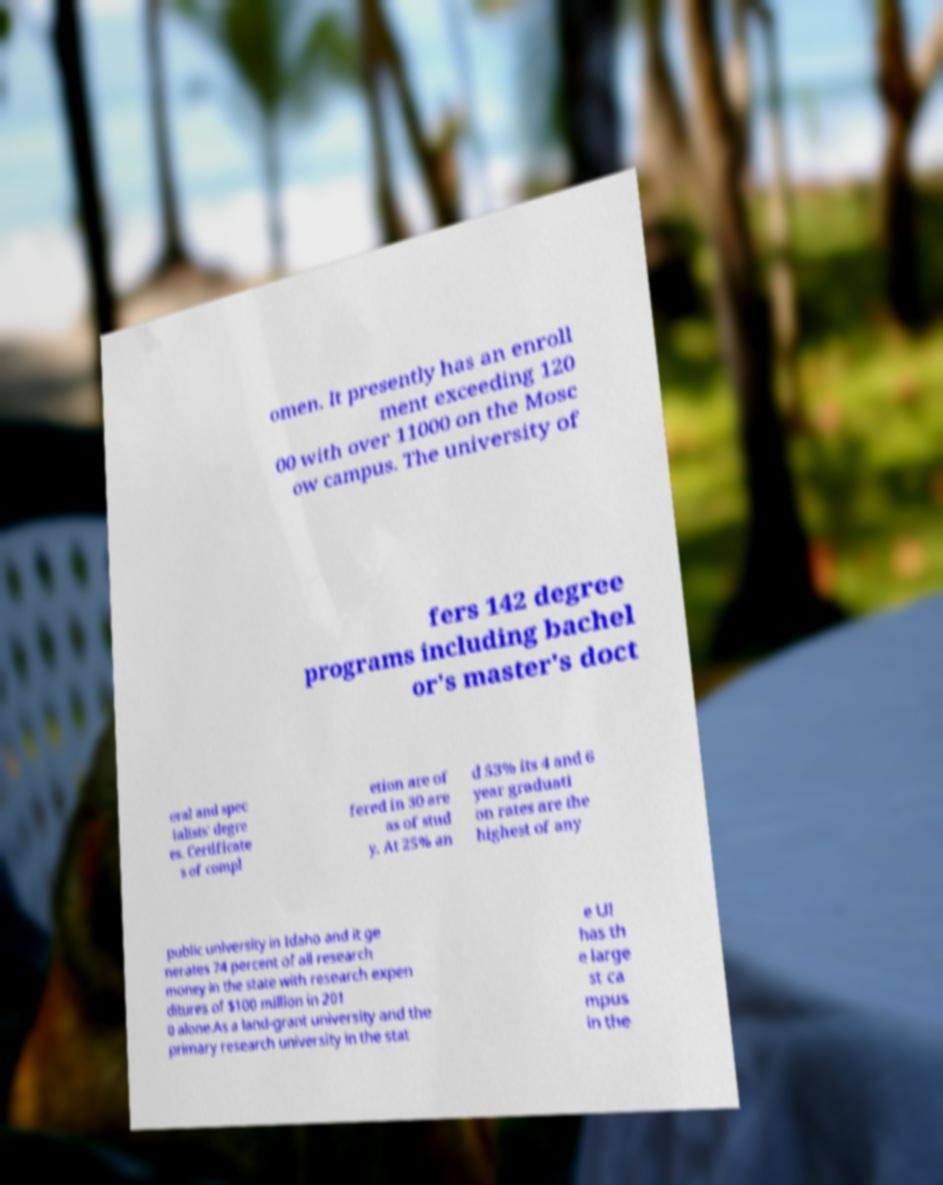What messages or text are displayed in this image? I need them in a readable, typed format. omen. It presently has an enroll ment exceeding 120 00 with over 11000 on the Mosc ow campus. The university of fers 142 degree programs including bachel or's master's doct oral and spec ialists' degre es. Certificate s of compl etion are of fered in 30 are as of stud y. At 25% an d 53% its 4 and 6 year graduati on rates are the highest of any public university in Idaho and it ge nerates 74 percent of all research money in the state with research expen ditures of $100 million in 201 0 alone.As a land-grant university and the primary research university in the stat e UI has th e large st ca mpus in the 